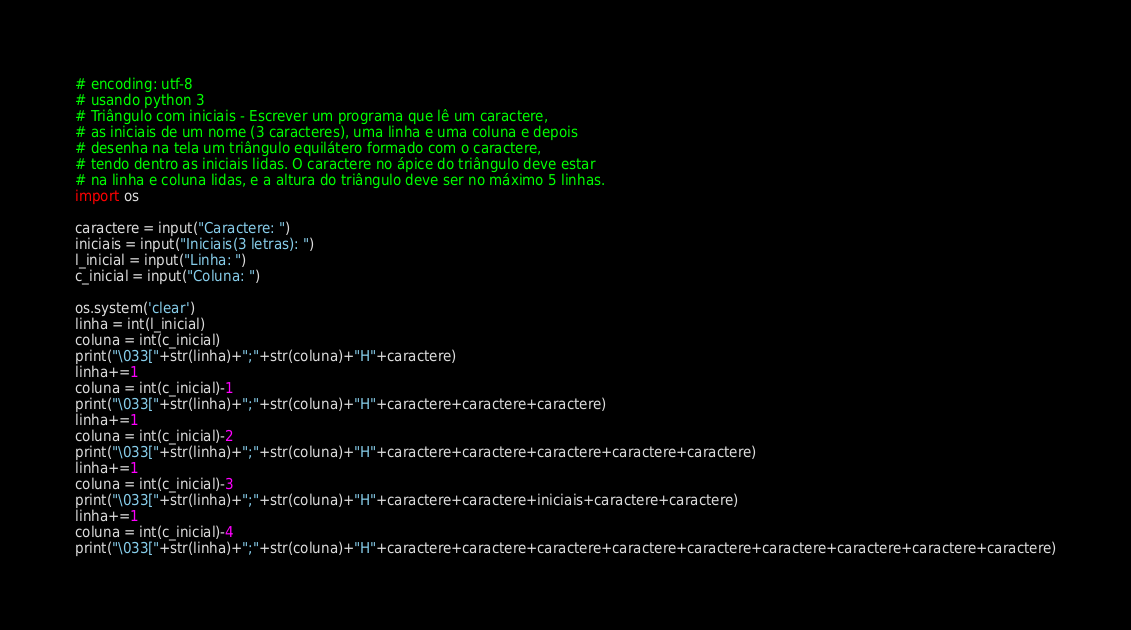<code> <loc_0><loc_0><loc_500><loc_500><_Python_># encoding: utf-8 
# usando python 3
# Triângulo com iniciais - Escrever um programa que lê um caractere, 
# as iniciais de um nome (3 caracteres), uma linha e uma coluna e depois 
# desenha na tela um triângulo equilátero formado com o caractere, 
# tendo dentro as iniciais lidas. O caractere no ápice do triângulo deve estar 
# na linha e coluna lidas, e a altura do triângulo deve ser no máximo 5 linhas.
import os

caractere = input("Caractere: ")
iniciais = input("Iniciais(3 letras): ")
l_inicial = input("Linha: ")
c_inicial = input("Coluna: ")

os.system('clear')
linha = int(l_inicial)
coluna = int(c_inicial)
print("\033["+str(linha)+";"+str(coluna)+"H"+caractere)
linha+=1
coluna = int(c_inicial)-1
print("\033["+str(linha)+";"+str(coluna)+"H"+caractere+caractere+caractere)
linha+=1
coluna = int(c_inicial)-2
print("\033["+str(linha)+";"+str(coluna)+"H"+caractere+caractere+caractere+caractere+caractere)
linha+=1
coluna = int(c_inicial)-3
print("\033["+str(linha)+";"+str(coluna)+"H"+caractere+caractere+iniciais+caractere+caractere)
linha+=1
coluna = int(c_inicial)-4
print("\033["+str(linha)+";"+str(coluna)+"H"+caractere+caractere+caractere+caractere+caractere+caractere+caractere+caractere+caractere)
</code> 